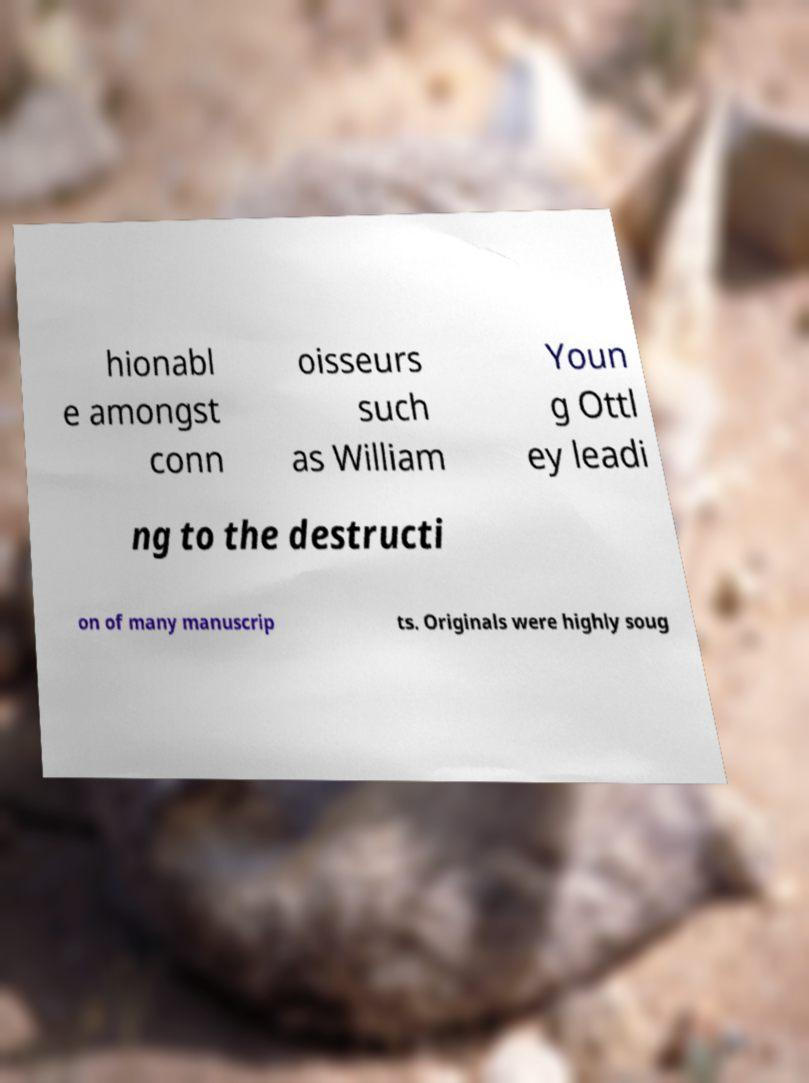Could you assist in decoding the text presented in this image and type it out clearly? hionabl e amongst conn oisseurs such as William Youn g Ottl ey leadi ng to the destructi on of many manuscrip ts. Originals were highly soug 